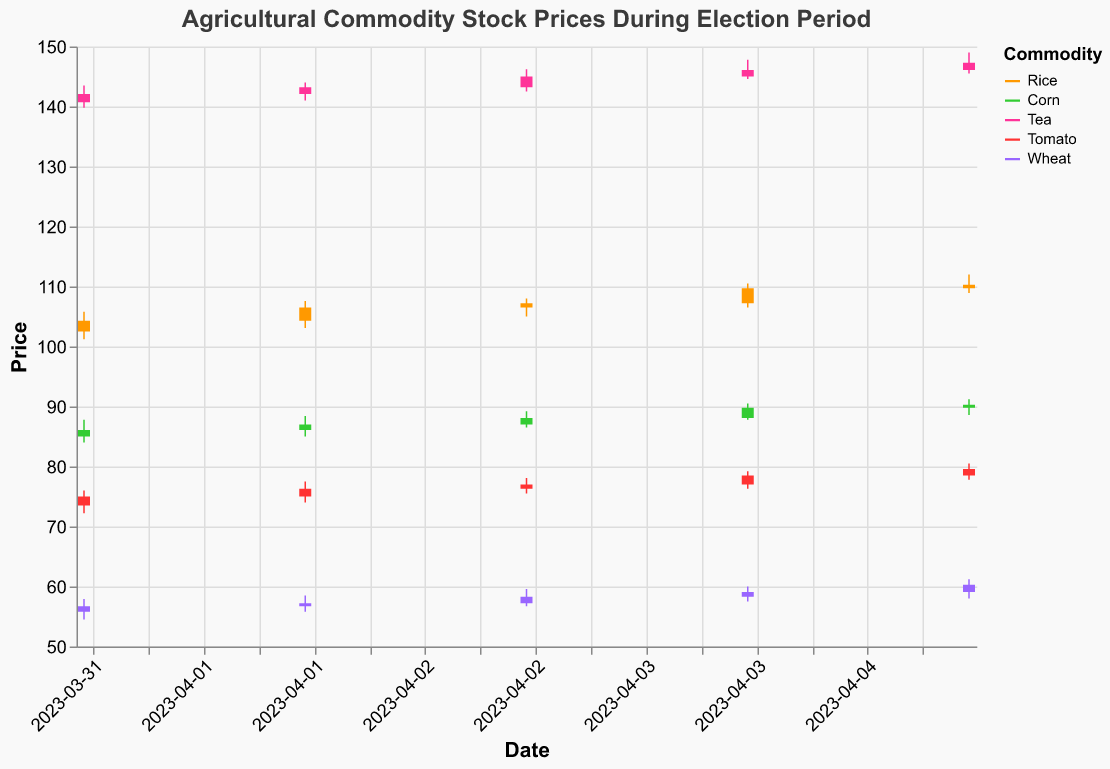When did the highest closing price for Rice occur in this period? Refer to the dates on the x-axis and look at the color corresponding to Rice. Identify the candlestick with the highest closing price.
Answer: 2023-04-05 Which commodity had the highest closing price on 2023-04-03? Check the closing prices on 2023-04-03 for each commodity by referring to the color legends. Determine which one is the highest.
Answer: Tea How does the closing price trend for Tomato compare from 2023-04-01 to 2023-04-05? Look at the closing prices of Tomato for each date from 2023-04-01 to 2023-04-05 and describe the trend. The values are 75.0, 76.3, 77.0, 78.5, and 79.6.
Answer: Increasing Which commodity had the highest volatility during this period? Calculate the range (High - Low) for each commodity on each date, then check which commodity has the largest range overall. Compare the ranges to determine which one is highest.
Answer: Rice On which date did Rice have its largest intra-day price range? For Rice, compute the difference between High and Low for each date and find the date with the largest difference.
Answer: 2023-04-04 